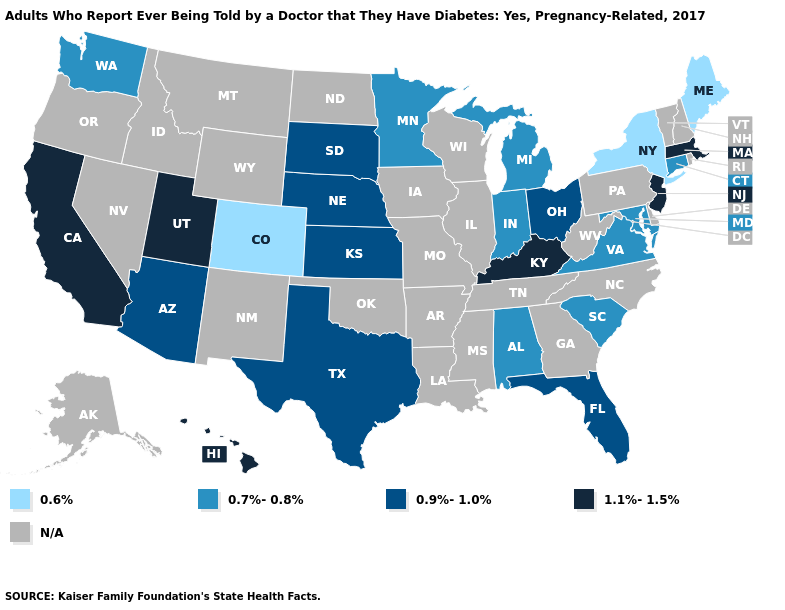Which states hav the highest value in the West?
Give a very brief answer. California, Hawaii, Utah. What is the value of California?
Write a very short answer. 1.1%-1.5%. Name the states that have a value in the range 1.1%-1.5%?
Keep it brief. California, Hawaii, Kentucky, Massachusetts, New Jersey, Utah. What is the value of Florida?
Answer briefly. 0.9%-1.0%. Name the states that have a value in the range 0.9%-1.0%?
Answer briefly. Arizona, Florida, Kansas, Nebraska, Ohio, South Dakota, Texas. Name the states that have a value in the range 1.1%-1.5%?
Concise answer only. California, Hawaii, Kentucky, Massachusetts, New Jersey, Utah. What is the highest value in the West ?
Keep it brief. 1.1%-1.5%. What is the lowest value in states that border Oregon?
Answer briefly. 0.7%-0.8%. What is the value of Maryland?
Answer briefly. 0.7%-0.8%. Name the states that have a value in the range 1.1%-1.5%?
Write a very short answer. California, Hawaii, Kentucky, Massachusetts, New Jersey, Utah. What is the value of West Virginia?
Be succinct. N/A. Does Maine have the highest value in the Northeast?
Give a very brief answer. No. What is the value of Oklahoma?
Short answer required. N/A. Name the states that have a value in the range 0.9%-1.0%?
Give a very brief answer. Arizona, Florida, Kansas, Nebraska, Ohio, South Dakota, Texas. 